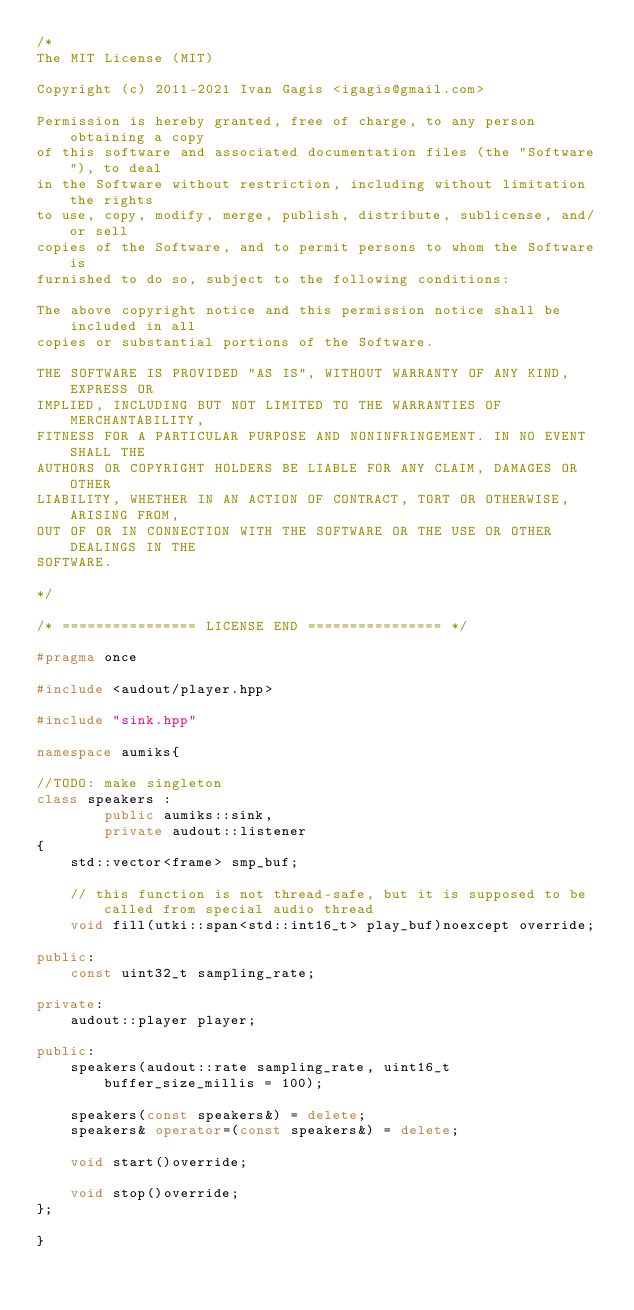Convert code to text. <code><loc_0><loc_0><loc_500><loc_500><_C++_>/*
The MIT License (MIT)

Copyright (c) 2011-2021 Ivan Gagis <igagis@gmail.com>

Permission is hereby granted, free of charge, to any person obtaining a copy
of this software and associated documentation files (the "Software"), to deal
in the Software without restriction, including without limitation the rights
to use, copy, modify, merge, publish, distribute, sublicense, and/or sell
copies of the Software, and to permit persons to whom the Software is
furnished to do so, subject to the following conditions:

The above copyright notice and this permission notice shall be included in all
copies or substantial portions of the Software.

THE SOFTWARE IS PROVIDED "AS IS", WITHOUT WARRANTY OF ANY KIND, EXPRESS OR
IMPLIED, INCLUDING BUT NOT LIMITED TO THE WARRANTIES OF MERCHANTABILITY,
FITNESS FOR A PARTICULAR PURPOSE AND NONINFRINGEMENT. IN NO EVENT SHALL THE
AUTHORS OR COPYRIGHT HOLDERS BE LIABLE FOR ANY CLAIM, DAMAGES OR OTHER
LIABILITY, WHETHER IN AN ACTION OF CONTRACT, TORT OR OTHERWISE, ARISING FROM,
OUT OF OR IN CONNECTION WITH THE SOFTWARE OR THE USE OR OTHER DEALINGS IN THE
SOFTWARE.

*/

/* ================ LICENSE END ================ */

#pragma once

#include <audout/player.hpp>

#include "sink.hpp"

namespace aumiks{

//TODO: make singleton
class speakers :
		public aumiks::sink,
		private audout::listener
{
	std::vector<frame> smp_buf;

	// this function is not thread-safe, but it is supposed to be called from special audio thread
	void fill(utki::span<std::int16_t> play_buf)noexcept override;
	
public:
	const uint32_t sampling_rate;
	
private:
	audout::player player;
	
public:
	speakers(audout::rate sampling_rate, uint16_t buffer_size_millis = 100);

	speakers(const speakers&) = delete;
	speakers& operator=(const speakers&) = delete;
	
	void start()override;

	void stop()override;
};

}
</code> 